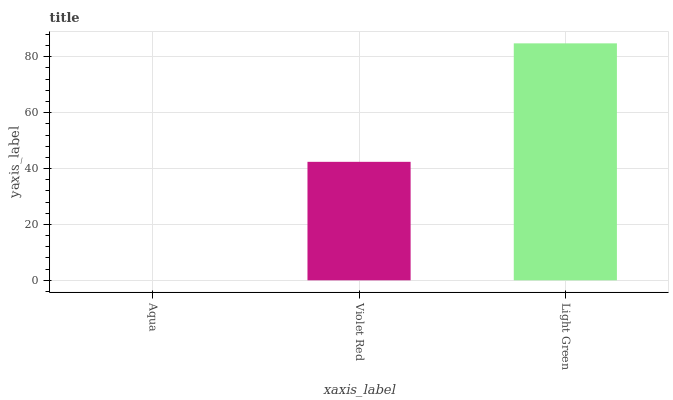Is Light Green the maximum?
Answer yes or no. Yes. Is Violet Red the minimum?
Answer yes or no. No. Is Violet Red the maximum?
Answer yes or no. No. Is Violet Red greater than Aqua?
Answer yes or no. Yes. Is Aqua less than Violet Red?
Answer yes or no. Yes. Is Aqua greater than Violet Red?
Answer yes or no. No. Is Violet Red less than Aqua?
Answer yes or no. No. Is Violet Red the high median?
Answer yes or no. Yes. Is Violet Red the low median?
Answer yes or no. Yes. Is Light Green the high median?
Answer yes or no. No. Is Aqua the low median?
Answer yes or no. No. 